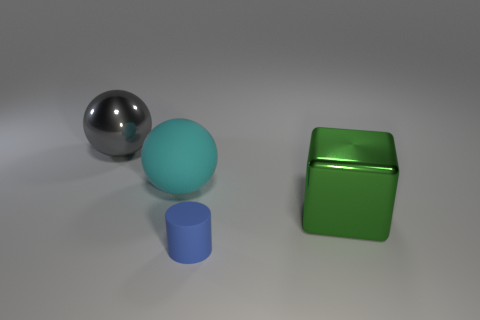Are there any cyan things that have the same size as the block?
Provide a short and direct response. Yes. Does the rubber thing left of the blue object have the same size as the gray thing?
Your response must be concise. Yes. Are there more big yellow blocks than tiny objects?
Make the answer very short. No. Are there any metallic objects that have the same shape as the big matte thing?
Provide a succinct answer. Yes. What shape is the matte thing that is behind the green metal block?
Offer a very short reply. Sphere. There is a rubber ball that is behind the rubber thing to the right of the cyan matte object; how many green shiny objects are to the left of it?
Keep it short and to the point. 0. Do the tiny matte object left of the large shiny block and the matte sphere have the same color?
Give a very brief answer. No. What number of other things are there of the same shape as the large green metal thing?
Your answer should be very brief. 0. What is the material of the object in front of the thing that is to the right of the rubber thing that is in front of the large green cube?
Offer a very short reply. Rubber. Is the block made of the same material as the tiny blue object?
Provide a succinct answer. No. 